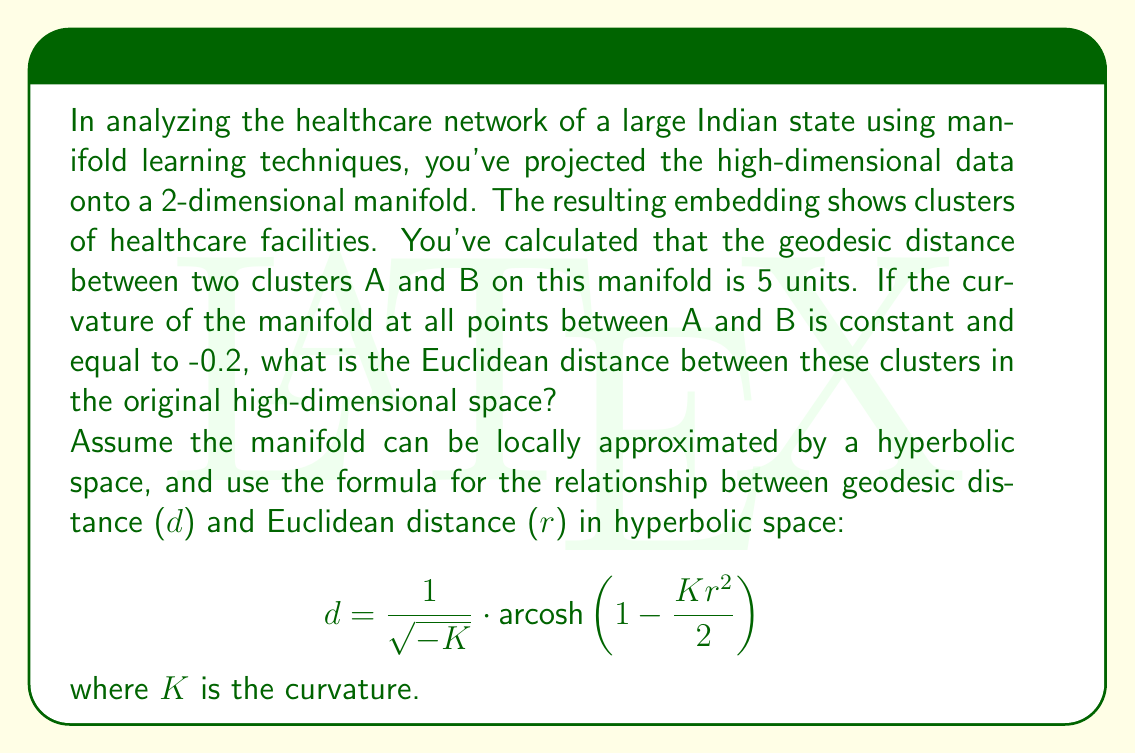Give your solution to this math problem. To solve this problem, we'll use the given formula that relates geodesic distance ($d$) to Euclidean distance ($r$) in a hyperbolic space with constant curvature $K$. We'll follow these steps:

1) We're given:
   - Geodesic distance $d = 5$ units
   - Curvature $K = -0.2$

2) Let's substitute these values into the formula:

   $$ 5 = \frac{1}{\sqrt{0.2}} \cdot \text{arcosh}(1 + \frac{0.2r^2}{2}) $$

3) Let's simplify the left side:

   $$ 5\sqrt{0.2} = \text{arcosh}(1 + \frac{0.2r^2}{2}) $$

4) Apply $\cosh$ to both sides:

   $$ \cosh(5\sqrt{0.2}) = 1 + \frac{0.2r^2}{2} $$

5) Subtract 1 from both sides:

   $$ \cosh(5\sqrt{0.2}) - 1 = \frac{0.2r^2}{2} $$

6) Multiply both sides by 2:

   $$ 2(\cosh(5\sqrt{0.2}) - 1) = 0.2r^2 $$

7) Divide both sides by 0.2:

   $$ \frac{2(\cosh(5\sqrt{0.2}) - 1)}{0.2} = r^2 $$

8) Take the square root of both sides:

   $$ r = \sqrt{\frac{2(\cosh(5\sqrt{0.2}) - 1)}{0.2}} $$

9) Calculate the value (you can use a calculator for this):

   $$ r \approx 11.18 $$

Therefore, the Euclidean distance between clusters A and B in the original high-dimensional space is approximately 11.18 units.
Answer: The Euclidean distance between clusters A and B in the original high-dimensional space is approximately 11.18 units. 